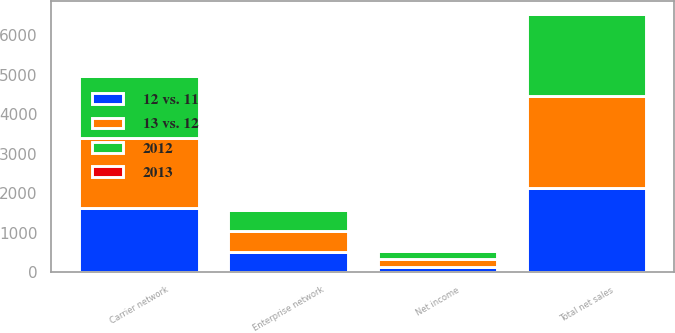Convert chart to OTSL. <chart><loc_0><loc_0><loc_500><loc_500><stacked_bar_chart><ecel><fcel>Carrier network<fcel>Enterprise network<fcel>Total net sales<fcel>Net income<nl><fcel>13 vs. 12<fcel>1782<fcel>544<fcel>2326<fcel>199<nl><fcel>12 vs. 11<fcel>1619<fcel>511<fcel>2130<fcel>146<nl><fcel>2012<fcel>1556<fcel>516<fcel>2072<fcel>194<nl><fcel>2013<fcel>10<fcel>6<fcel>9<fcel>36<nl></chart> 